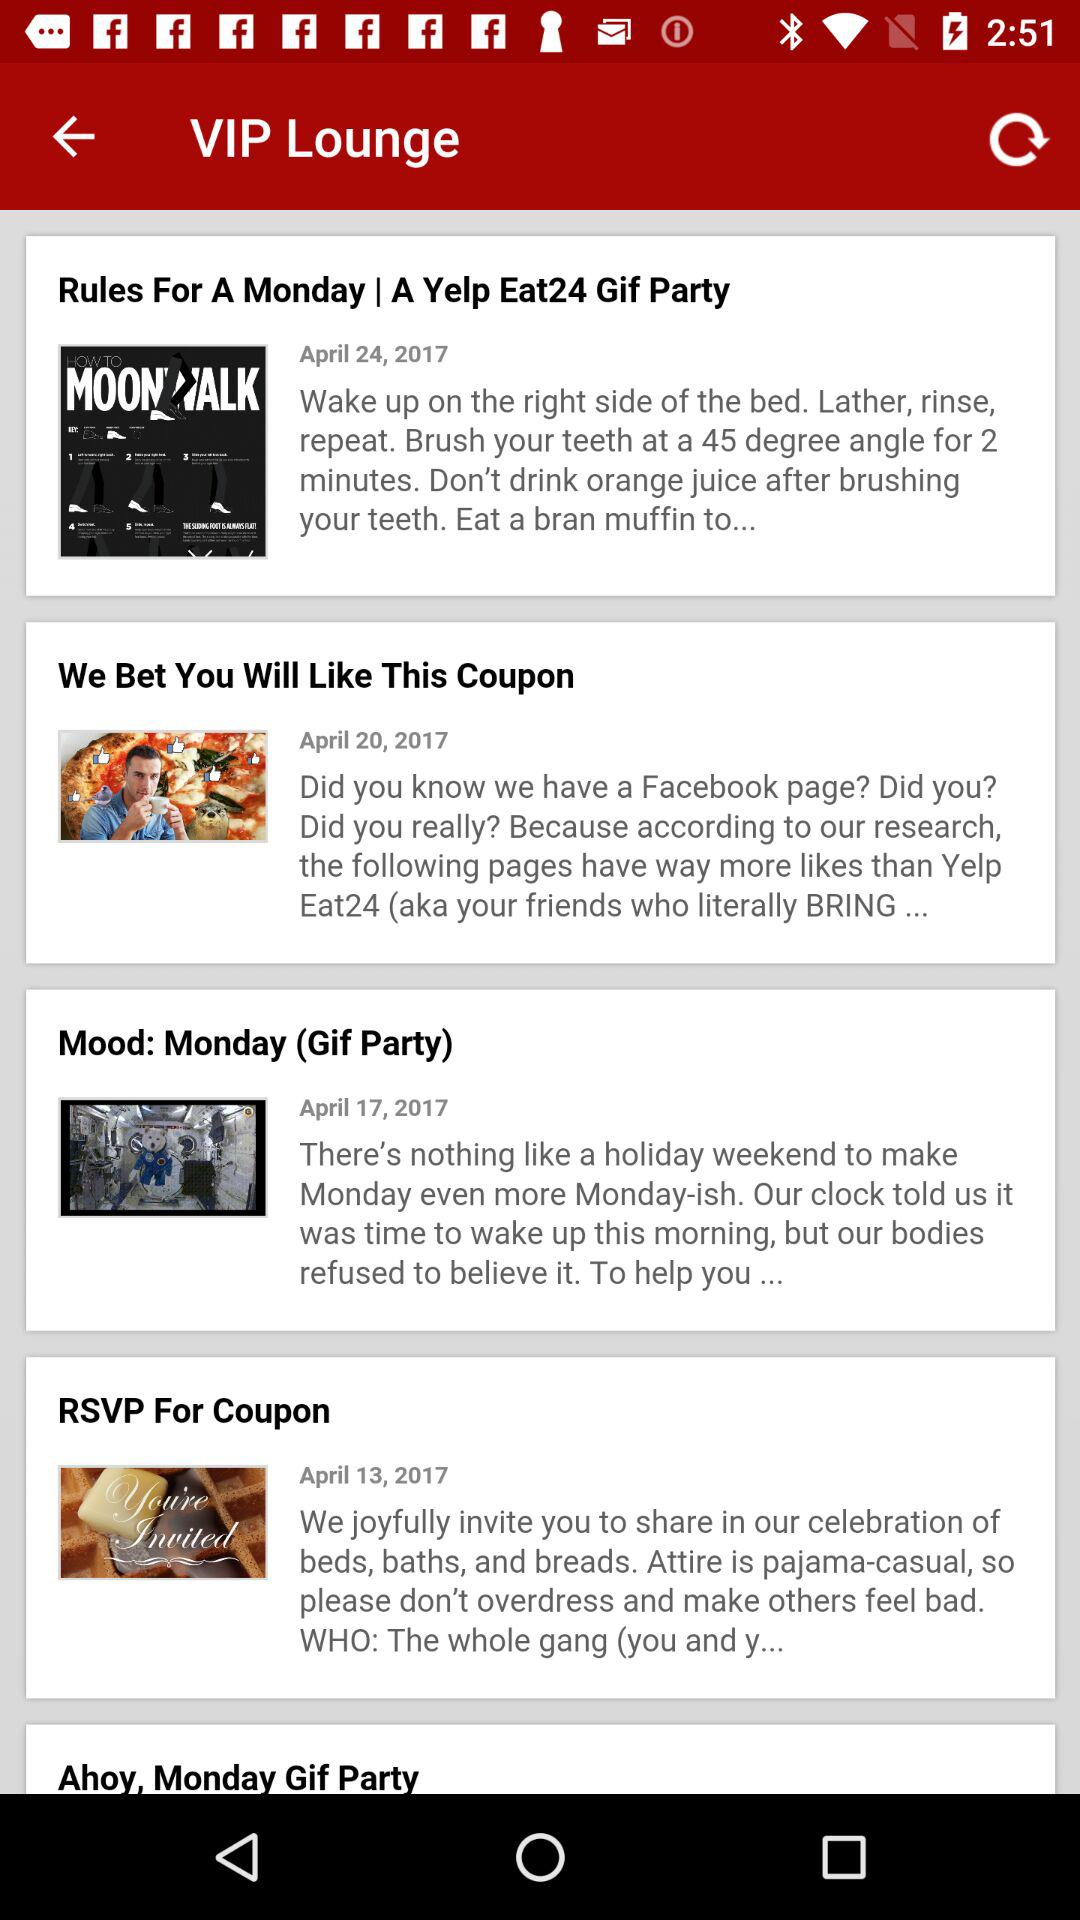On which date were the "Rules For A Monday" updated? The "Rules For A Monday" were updated on April 24, 2017. 